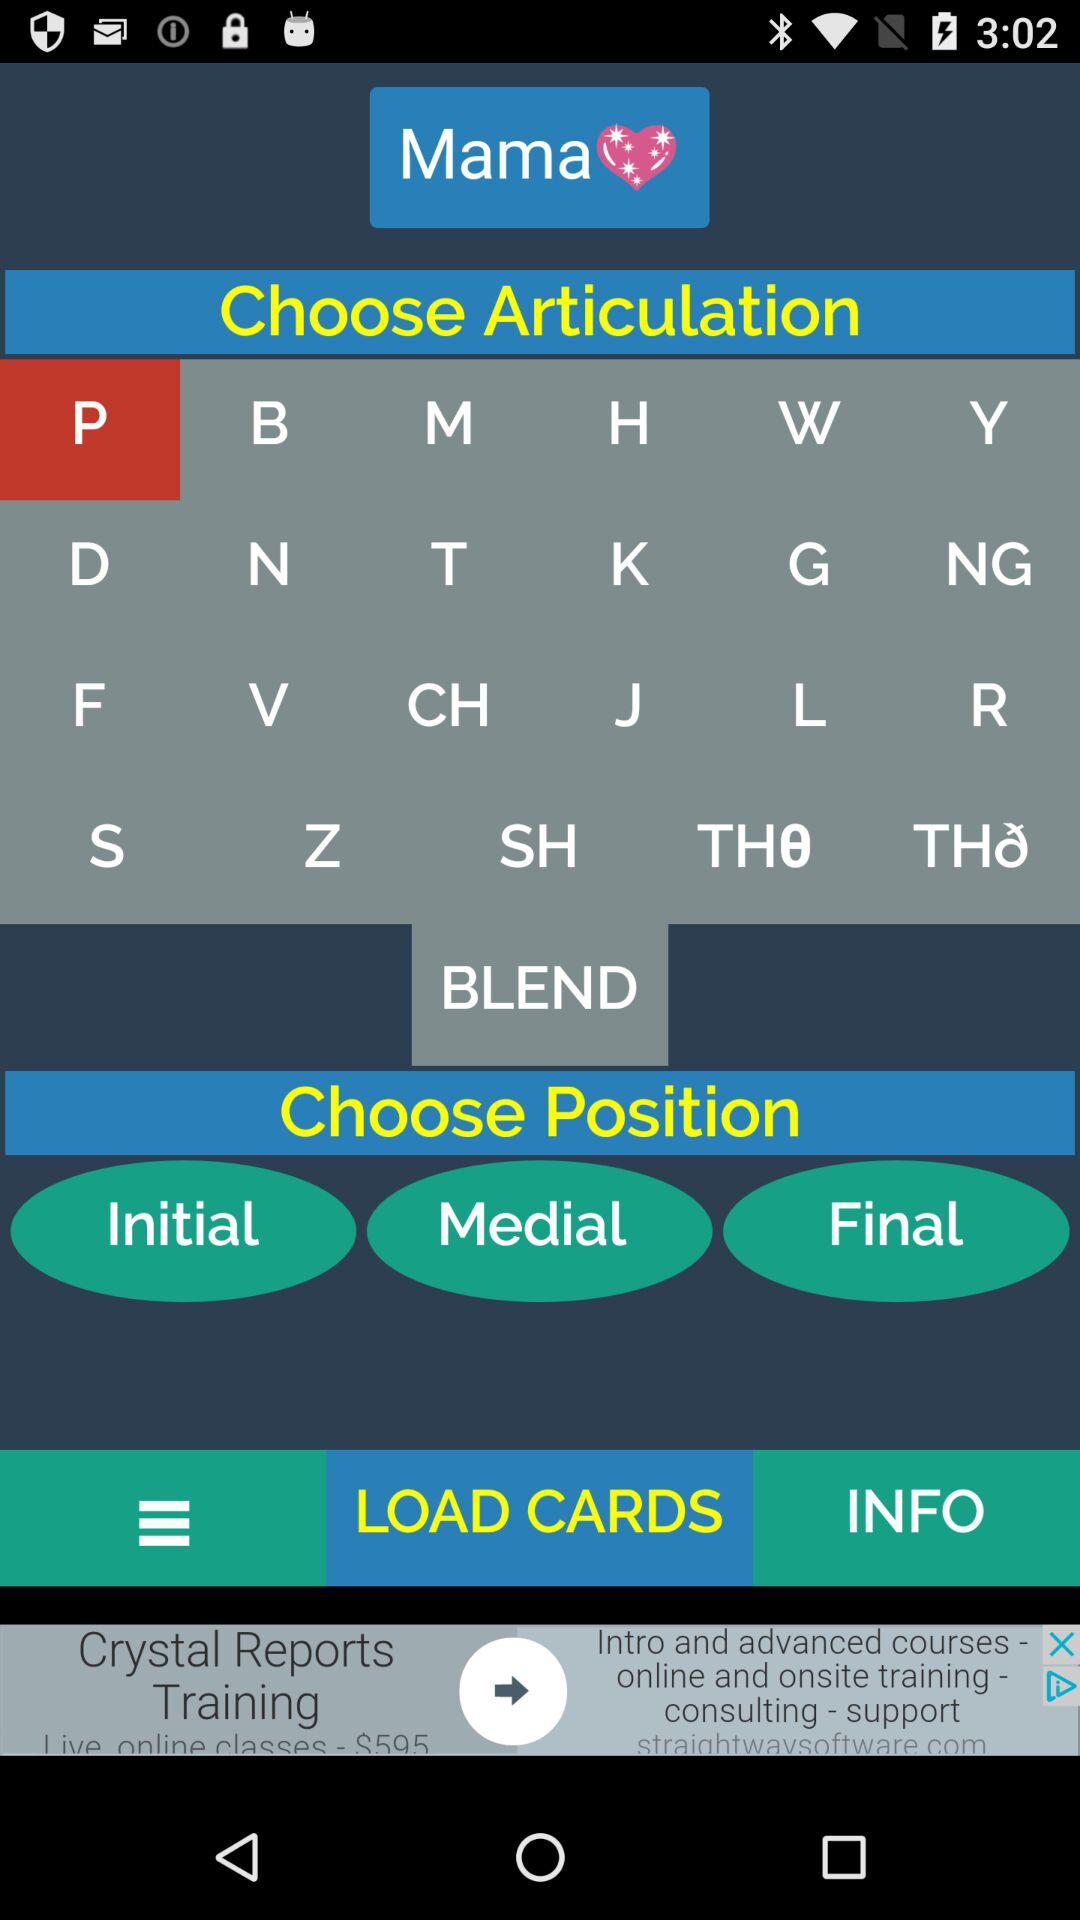What are the types of positions? The types of positions are "Initial", "Medial" and "Final". 